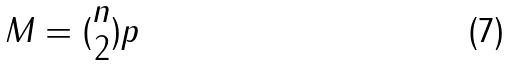Convert formula to latex. <formula><loc_0><loc_0><loc_500><loc_500>M = ( \begin{matrix} n \\ 2 \end{matrix} ) p</formula> 